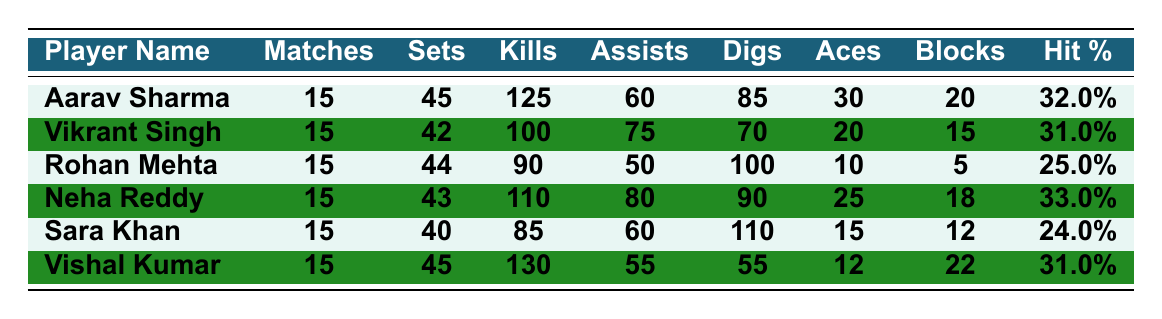What is the highest number of kills recorded by a player? Looking at the "Total Kills" column, the highest value is 130 by Vishal Kumar.
Answer: 130 Who has the highest ace count among the players? From the "Total Aces" column, Neha Reddy has the highest count with 25 aces.
Answer: 25 What is the average hit percentage of the players? To calculate the average, add the hit percentages: (32.0 + 31.0 + 25.0 + 33.0 + 24.0 + 31.0) = 176.0 and divide by 6 players. Thus, the average is 176.0 / 6 ≈ 29.33%.
Answer: 29.33% Is Rohan Mehta's number of assists greater than his number of blocks? Rohan Mehta's assists are 50 while his blocks are 5, which means 50 > 5 is true.
Answer: Yes What is the difference in total digs between the player with the most digs and the player with the least? The player with the most digs is Sara Khan with 110, and the player with the least is Vishal Kumar with 55. The difference is 110 - 55 = 55.
Answer: 55 Which player has the lowest hit percentage? By comparing the "Hit Percentage" column, Sara Khan has the lowest at 24.0%.
Answer: 24.0% How many total kills do the top two players combined have? Looking at the players with the highest kills, Aarav Sharma has 125 and Vishal Kumar has 130, thus their total kills are 125 + 130 = 255.
Answer: 255 Is it true that all players have played the same number of matches? All players have played 15 matches, therefore this statement is true.
Answer: Yes Which player has the most assists and how many did they have? From the table, Vikrant Singh has the most assists with a total of 75.
Answer: 75 Which player has both the highest number of kills and the highest number of digs? Aarav Sharma has the highest kills (125) but Neha Reddy has the highest digs (90); therefore, no player has both.
Answer: No player meets both criteria 